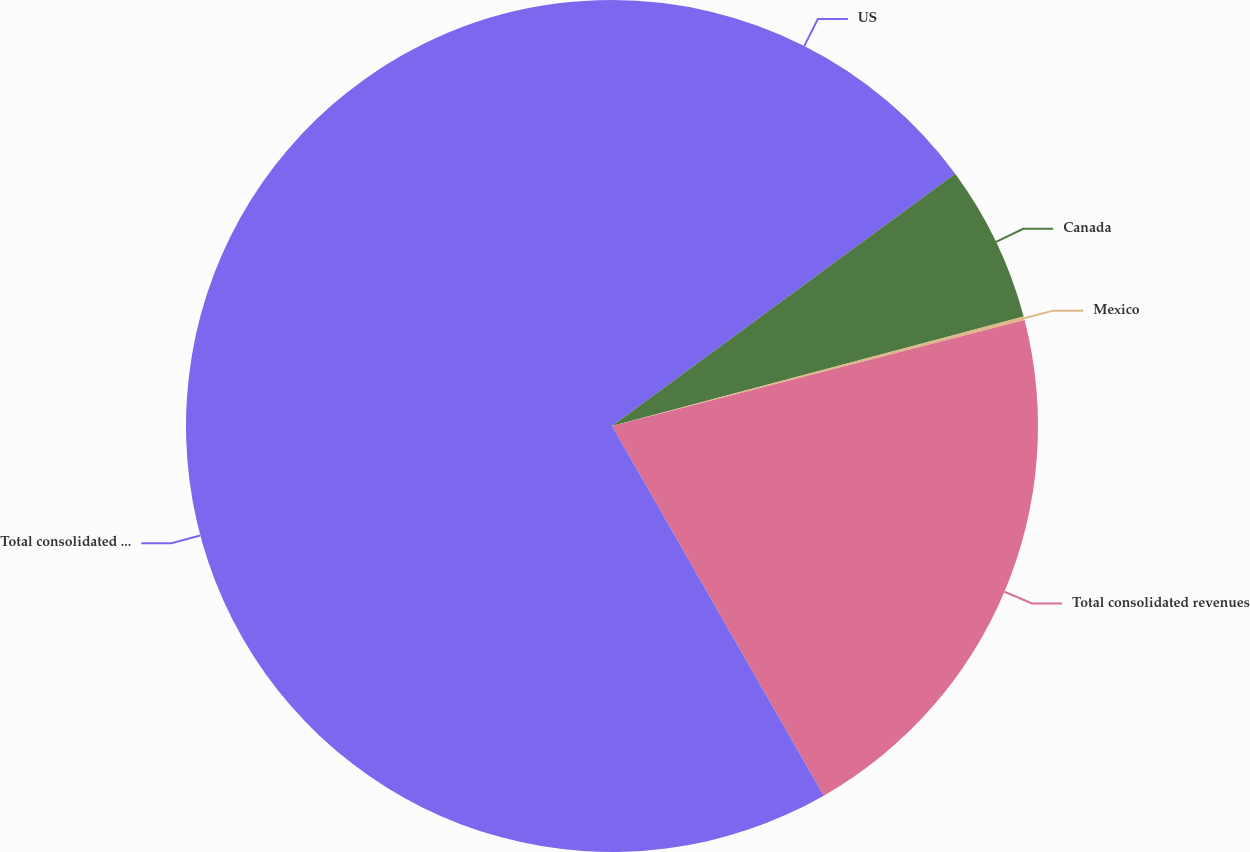Convert chart to OTSL. <chart><loc_0><loc_0><loc_500><loc_500><pie_chart><fcel>US<fcel>Canada<fcel>Mexico<fcel>Total consolidated revenues<fcel>Total consolidated long-lived<nl><fcel>14.91%<fcel>5.95%<fcel>0.14%<fcel>20.72%<fcel>58.28%<nl></chart> 